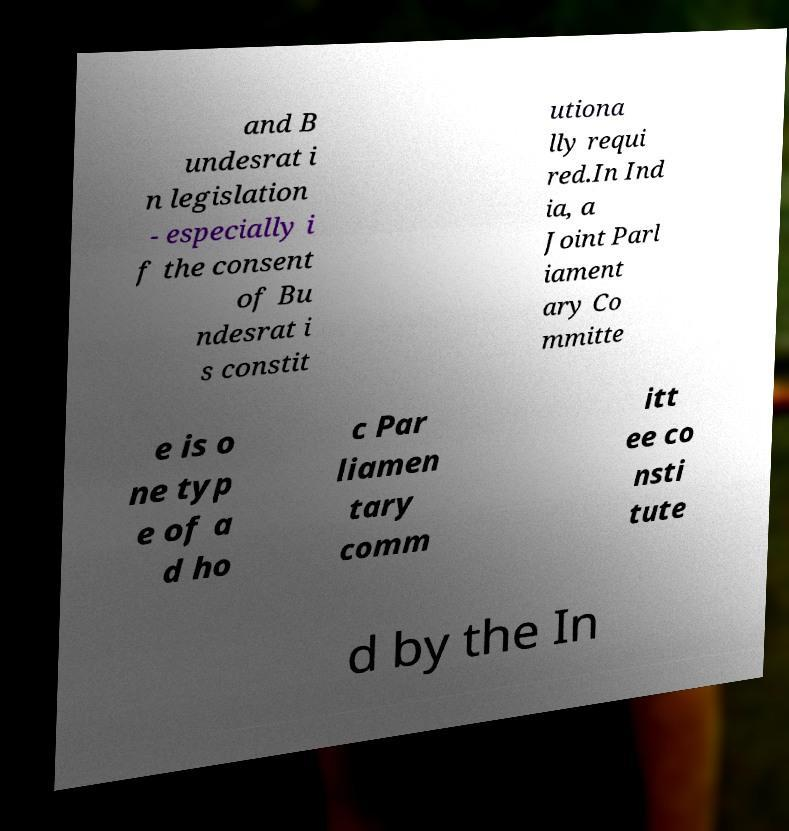What messages or text are displayed in this image? I need them in a readable, typed format. and B undesrat i n legislation - especially i f the consent of Bu ndesrat i s constit utiona lly requi red.In Ind ia, a Joint Parl iament ary Co mmitte e is o ne typ e of a d ho c Par liamen tary comm itt ee co nsti tute d by the In 